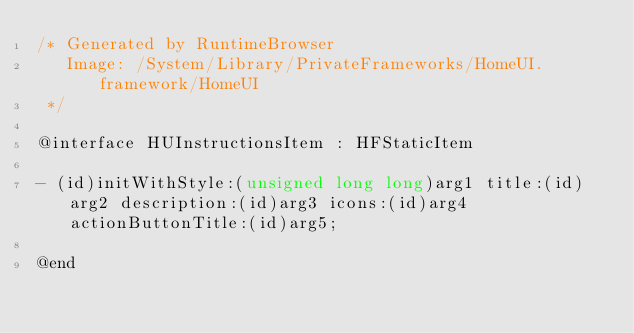Convert code to text. <code><loc_0><loc_0><loc_500><loc_500><_C_>/* Generated by RuntimeBrowser
   Image: /System/Library/PrivateFrameworks/HomeUI.framework/HomeUI
 */

@interface HUInstructionsItem : HFStaticItem

- (id)initWithStyle:(unsigned long long)arg1 title:(id)arg2 description:(id)arg3 icons:(id)arg4 actionButtonTitle:(id)arg5;

@end
</code> 